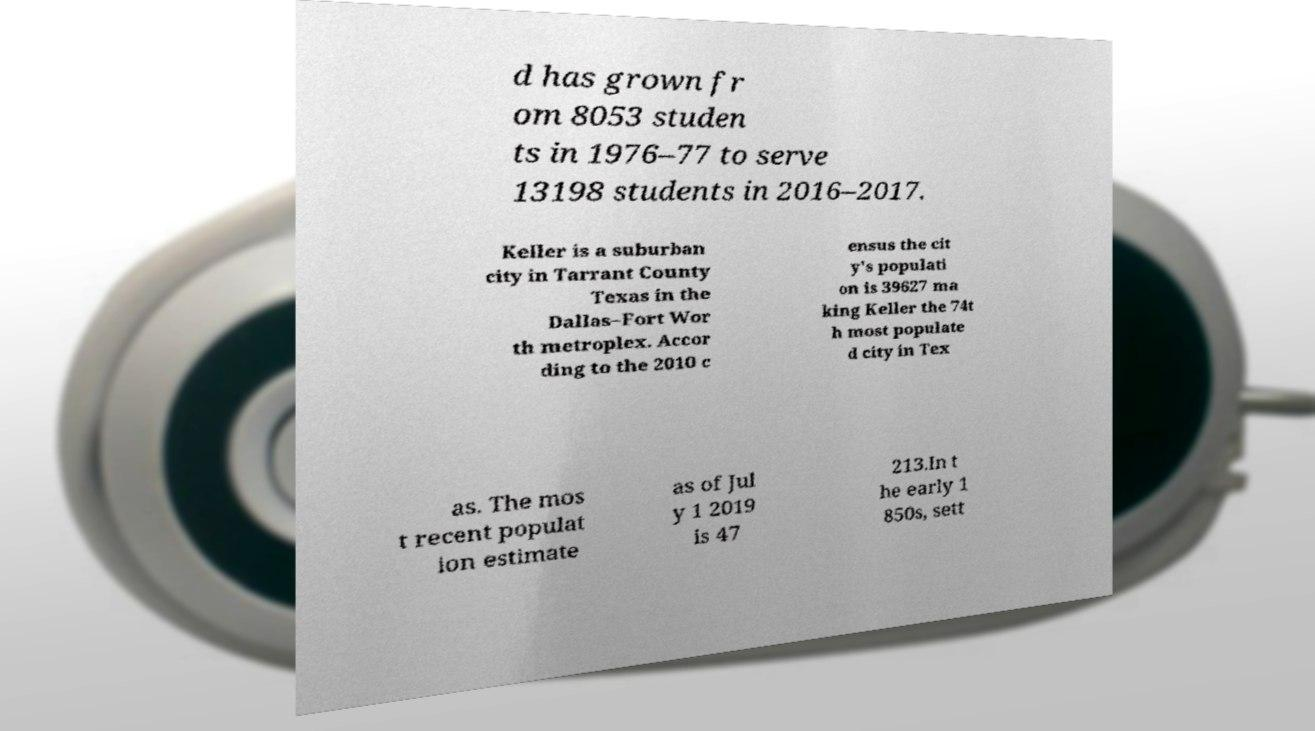Could you assist in decoding the text presented in this image and type it out clearly? d has grown fr om 8053 studen ts in 1976–77 to serve 13198 students in 2016–2017. Keller is a suburban city in Tarrant County Texas in the Dallas–Fort Wor th metroplex. Accor ding to the 2010 c ensus the cit y's populati on is 39627 ma king Keller the 74t h most populate d city in Tex as. The mos t recent populat ion estimate as of Jul y 1 2019 is 47 213.In t he early 1 850s, sett 